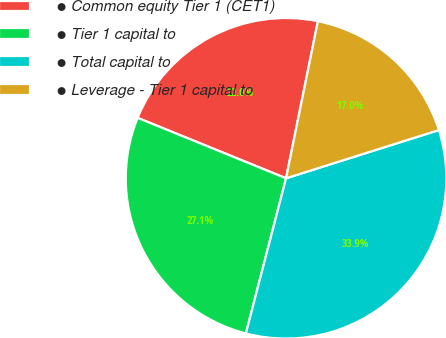Convert chart. <chart><loc_0><loc_0><loc_500><loc_500><pie_chart><fcel>● Common equity Tier 1 (CET1)<fcel>● Tier 1 capital to<fcel>● Total capital to<fcel>● Leverage - Tier 1 capital to<nl><fcel>22.03%<fcel>27.12%<fcel>33.9%<fcel>16.95%<nl></chart> 